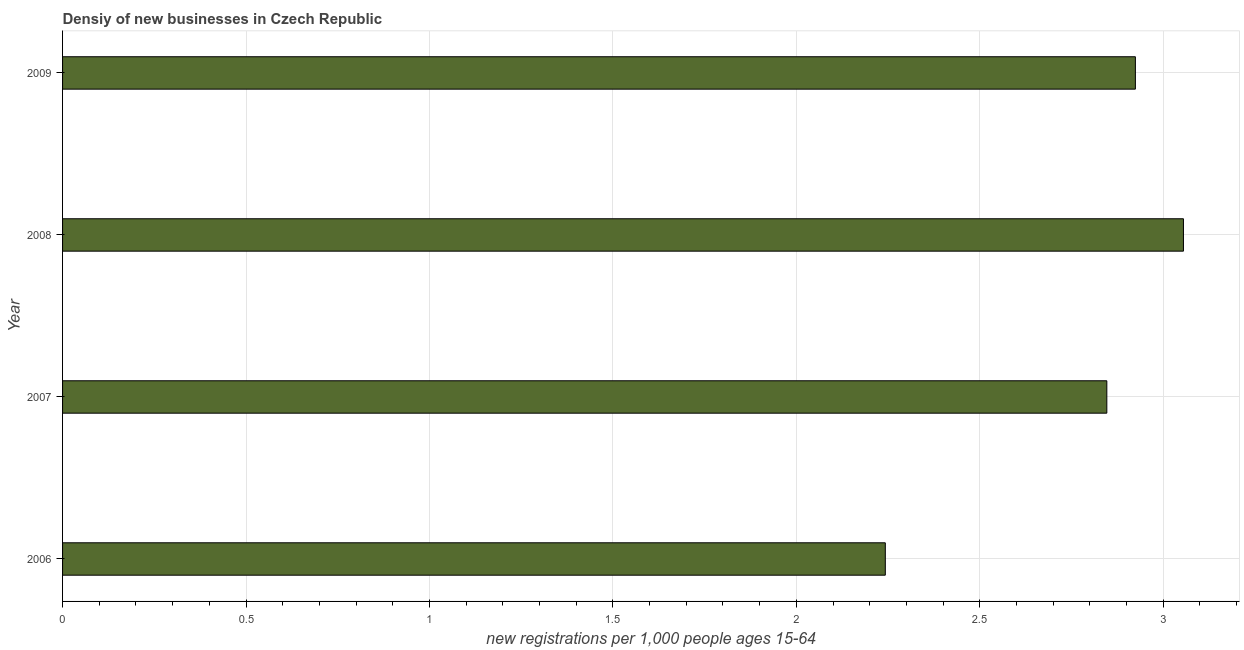Does the graph contain any zero values?
Your response must be concise. No. What is the title of the graph?
Make the answer very short. Densiy of new businesses in Czech Republic. What is the label or title of the X-axis?
Offer a very short reply. New registrations per 1,0 people ages 15-64. What is the label or title of the Y-axis?
Provide a succinct answer. Year. What is the density of new business in 2007?
Your answer should be very brief. 2.85. Across all years, what is the maximum density of new business?
Ensure brevity in your answer.  3.06. Across all years, what is the minimum density of new business?
Offer a terse response. 2.24. In which year was the density of new business maximum?
Ensure brevity in your answer.  2008. In which year was the density of new business minimum?
Give a very brief answer. 2006. What is the sum of the density of new business?
Offer a very short reply. 11.07. What is the difference between the density of new business in 2006 and 2007?
Give a very brief answer. -0.6. What is the average density of new business per year?
Provide a succinct answer. 2.77. What is the median density of new business?
Keep it short and to the point. 2.89. In how many years, is the density of new business greater than 2.6 ?
Give a very brief answer. 3. What is the ratio of the density of new business in 2006 to that in 2008?
Your answer should be compact. 0.73. Is the density of new business in 2007 less than that in 2008?
Your answer should be compact. Yes. What is the difference between the highest and the second highest density of new business?
Offer a terse response. 0.13. Is the sum of the density of new business in 2006 and 2009 greater than the maximum density of new business across all years?
Give a very brief answer. Yes. What is the difference between the highest and the lowest density of new business?
Offer a very short reply. 0.81. In how many years, is the density of new business greater than the average density of new business taken over all years?
Ensure brevity in your answer.  3. Are all the bars in the graph horizontal?
Keep it short and to the point. Yes. How many years are there in the graph?
Ensure brevity in your answer.  4. What is the new registrations per 1,000 people ages 15-64 in 2006?
Provide a succinct answer. 2.24. What is the new registrations per 1,000 people ages 15-64 in 2007?
Your answer should be compact. 2.85. What is the new registrations per 1,000 people ages 15-64 of 2008?
Make the answer very short. 3.06. What is the new registrations per 1,000 people ages 15-64 of 2009?
Your answer should be very brief. 2.92. What is the difference between the new registrations per 1,000 people ages 15-64 in 2006 and 2007?
Provide a short and direct response. -0.6. What is the difference between the new registrations per 1,000 people ages 15-64 in 2006 and 2008?
Offer a terse response. -0.81. What is the difference between the new registrations per 1,000 people ages 15-64 in 2006 and 2009?
Ensure brevity in your answer.  -0.68. What is the difference between the new registrations per 1,000 people ages 15-64 in 2007 and 2008?
Give a very brief answer. -0.21. What is the difference between the new registrations per 1,000 people ages 15-64 in 2007 and 2009?
Give a very brief answer. -0.08. What is the difference between the new registrations per 1,000 people ages 15-64 in 2008 and 2009?
Your answer should be very brief. 0.13. What is the ratio of the new registrations per 1,000 people ages 15-64 in 2006 to that in 2007?
Give a very brief answer. 0.79. What is the ratio of the new registrations per 1,000 people ages 15-64 in 2006 to that in 2008?
Offer a terse response. 0.73. What is the ratio of the new registrations per 1,000 people ages 15-64 in 2006 to that in 2009?
Give a very brief answer. 0.77. What is the ratio of the new registrations per 1,000 people ages 15-64 in 2007 to that in 2008?
Provide a succinct answer. 0.93. What is the ratio of the new registrations per 1,000 people ages 15-64 in 2008 to that in 2009?
Ensure brevity in your answer.  1.04. 